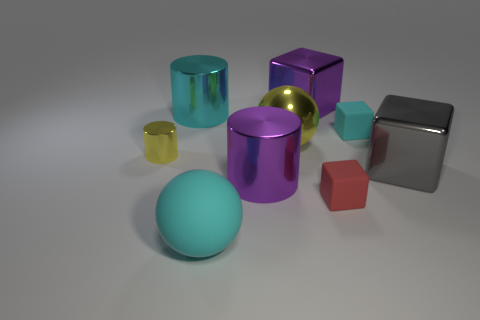The gray object has what size?
Your answer should be very brief. Large. What number of rubber blocks are on the right side of the small yellow cylinder?
Offer a terse response. 2. What is the size of the cyan matte thing on the left side of the cyan rubber thing that is behind the rubber sphere?
Keep it short and to the point. Large. There is a big shiny thing on the right side of the small cyan rubber block; is it the same shape as the purple metal object that is in front of the cyan rubber block?
Your response must be concise. No. There is a rubber thing left of the large shiny cube to the left of the tiny red matte cube; what is its shape?
Your response must be concise. Sphere. What is the size of the shiny thing that is both in front of the tiny yellow metal cylinder and to the left of the red rubber block?
Offer a very short reply. Large. Does the big cyan rubber thing have the same shape as the big purple metallic object behind the big purple metal cylinder?
Offer a terse response. No. There is a red matte object that is the same shape as the big gray metal thing; what size is it?
Your answer should be very brief. Small. Do the small metallic thing and the tiny matte thing that is in front of the big purple shiny cylinder have the same color?
Your response must be concise. No. How many other objects are there of the same size as the gray thing?
Offer a terse response. 5. 